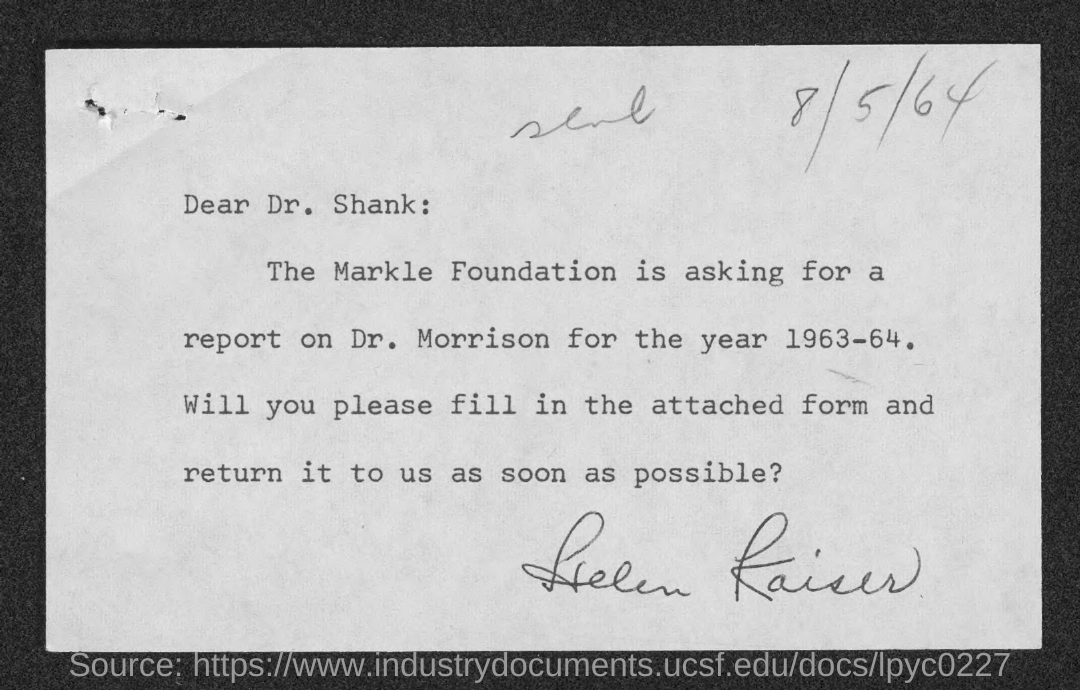What is the date mentioned in the top of the document ?
Ensure brevity in your answer.  8/5/64. Who is the receiver of the letter ?
Provide a short and direct response. Dr. Shank. 